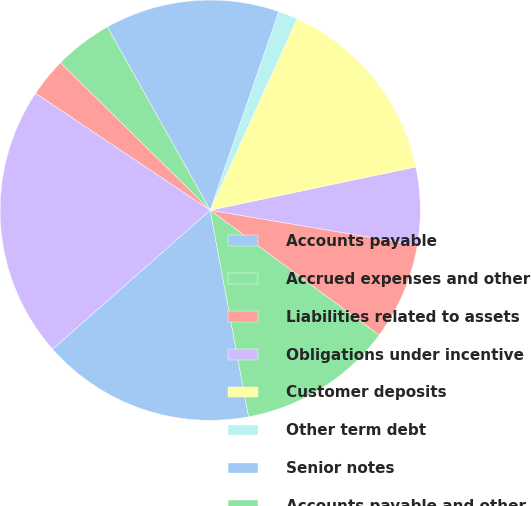Convert chart. <chart><loc_0><loc_0><loc_500><loc_500><pie_chart><fcel>Accounts payable<fcel>Accrued expenses and other<fcel>Liabilities related to assets<fcel>Obligations under incentive<fcel>Customer deposits<fcel>Other term debt<fcel>Senior notes<fcel>Accounts payable and other<fcel>Notes payable<fcel>Total liabilities<nl><fcel>16.42%<fcel>11.94%<fcel>7.46%<fcel>5.97%<fcel>14.92%<fcel>1.49%<fcel>13.43%<fcel>4.48%<fcel>2.99%<fcel>20.89%<nl></chart> 